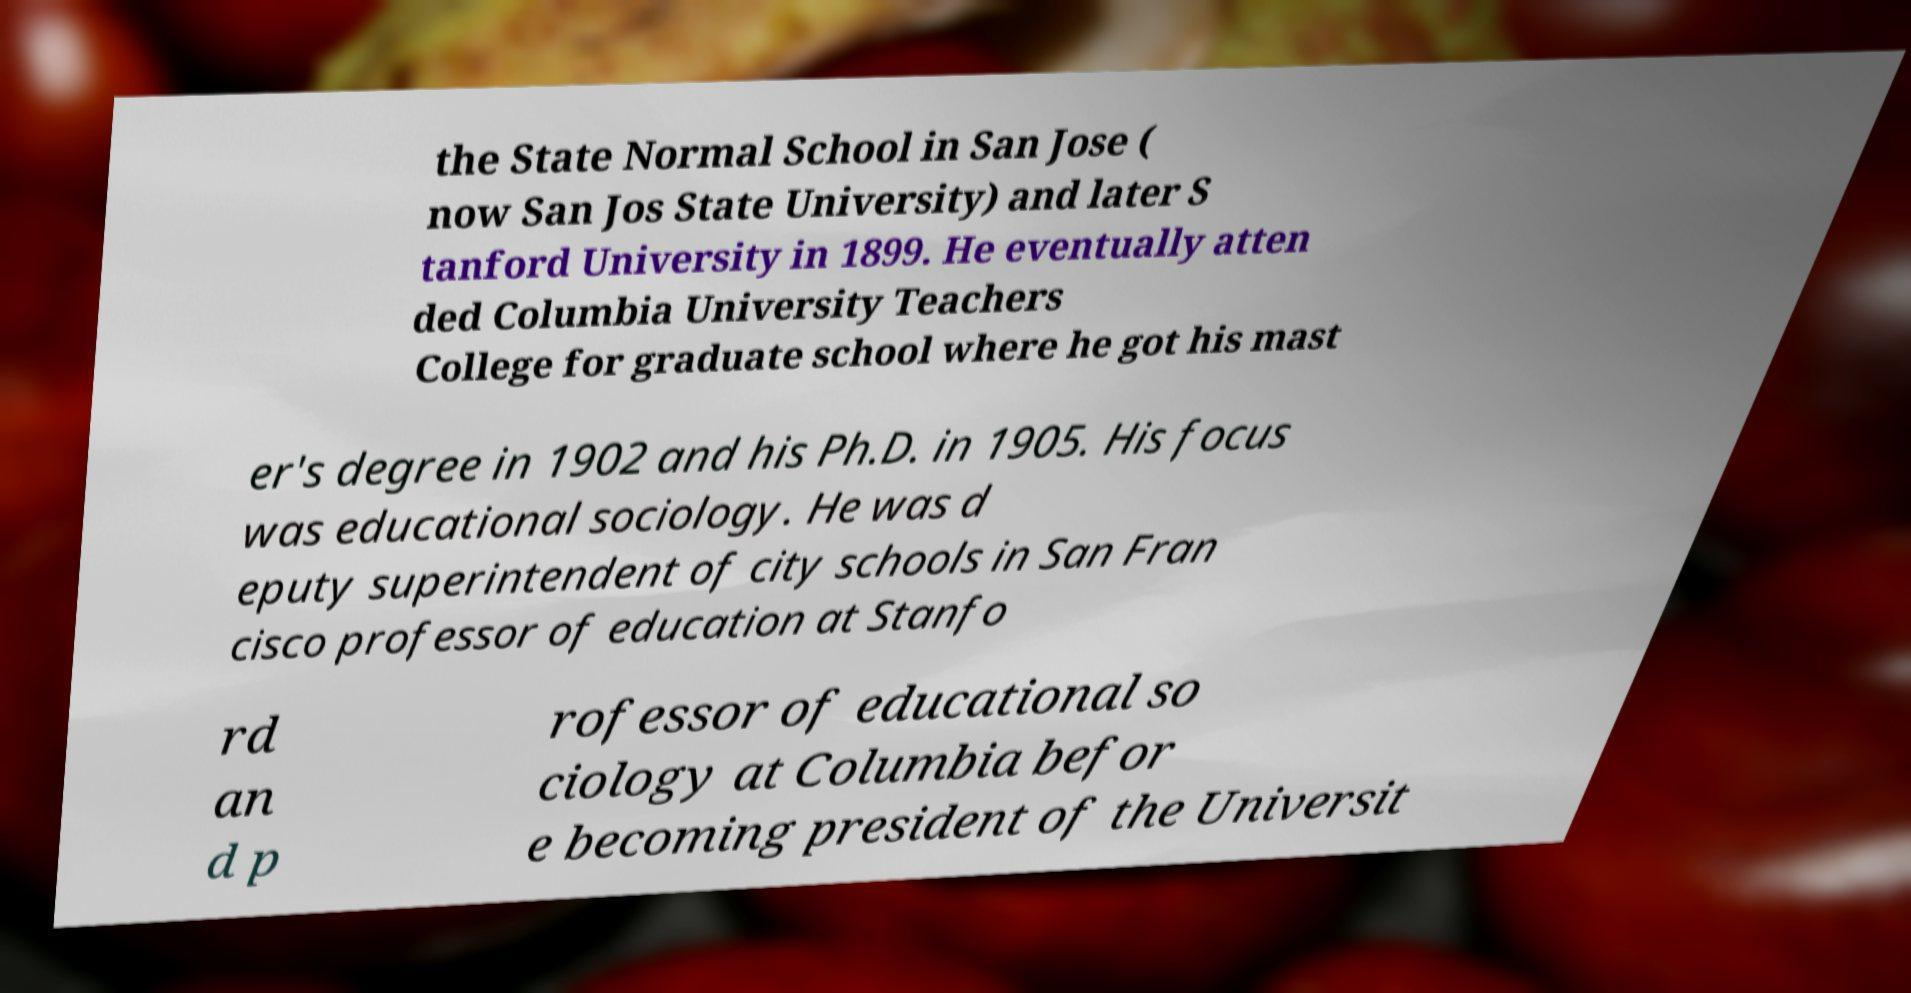For documentation purposes, I need the text within this image transcribed. Could you provide that? the State Normal School in San Jose ( now San Jos State University) and later S tanford University in 1899. He eventually atten ded Columbia University Teachers College for graduate school where he got his mast er's degree in 1902 and his Ph.D. in 1905. His focus was educational sociology. He was d eputy superintendent of city schools in San Fran cisco professor of education at Stanfo rd an d p rofessor of educational so ciology at Columbia befor e becoming president of the Universit 